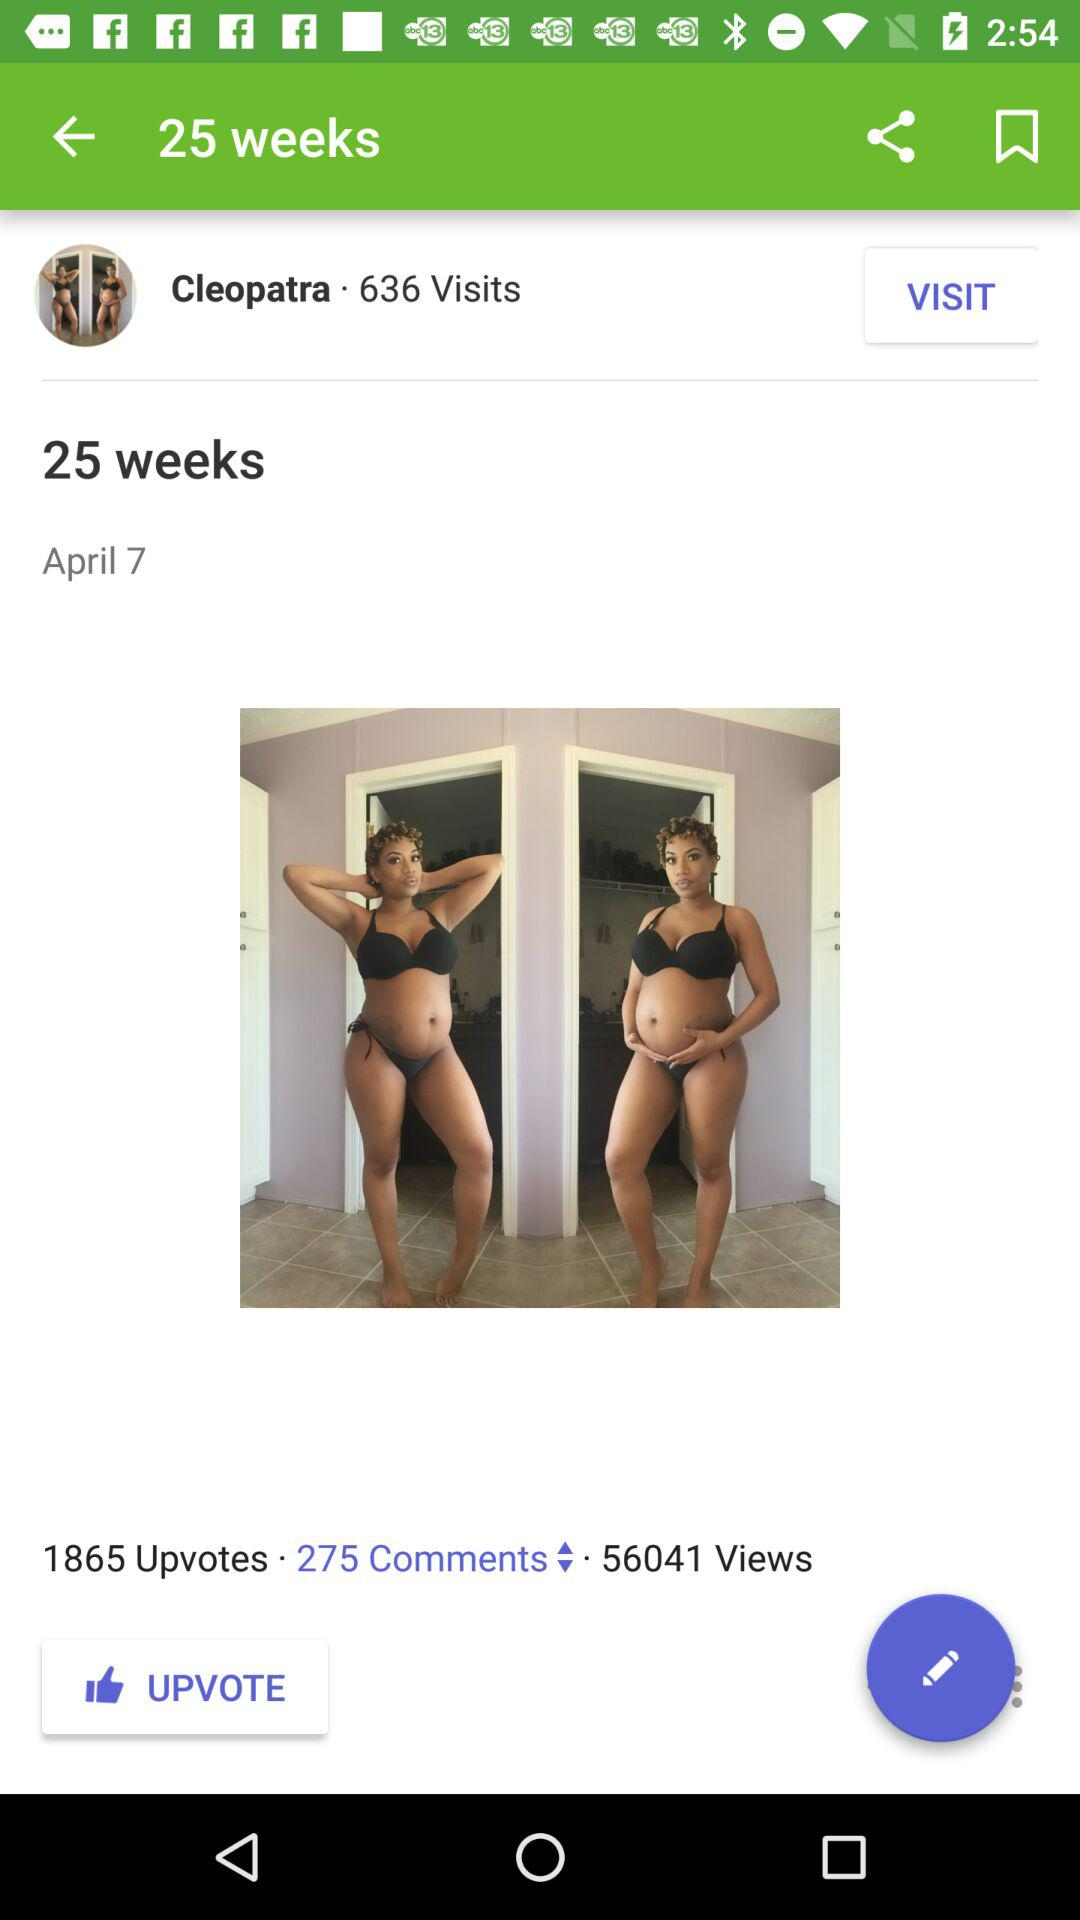What is the number of upvotes? The number of upvotes is 1865. 